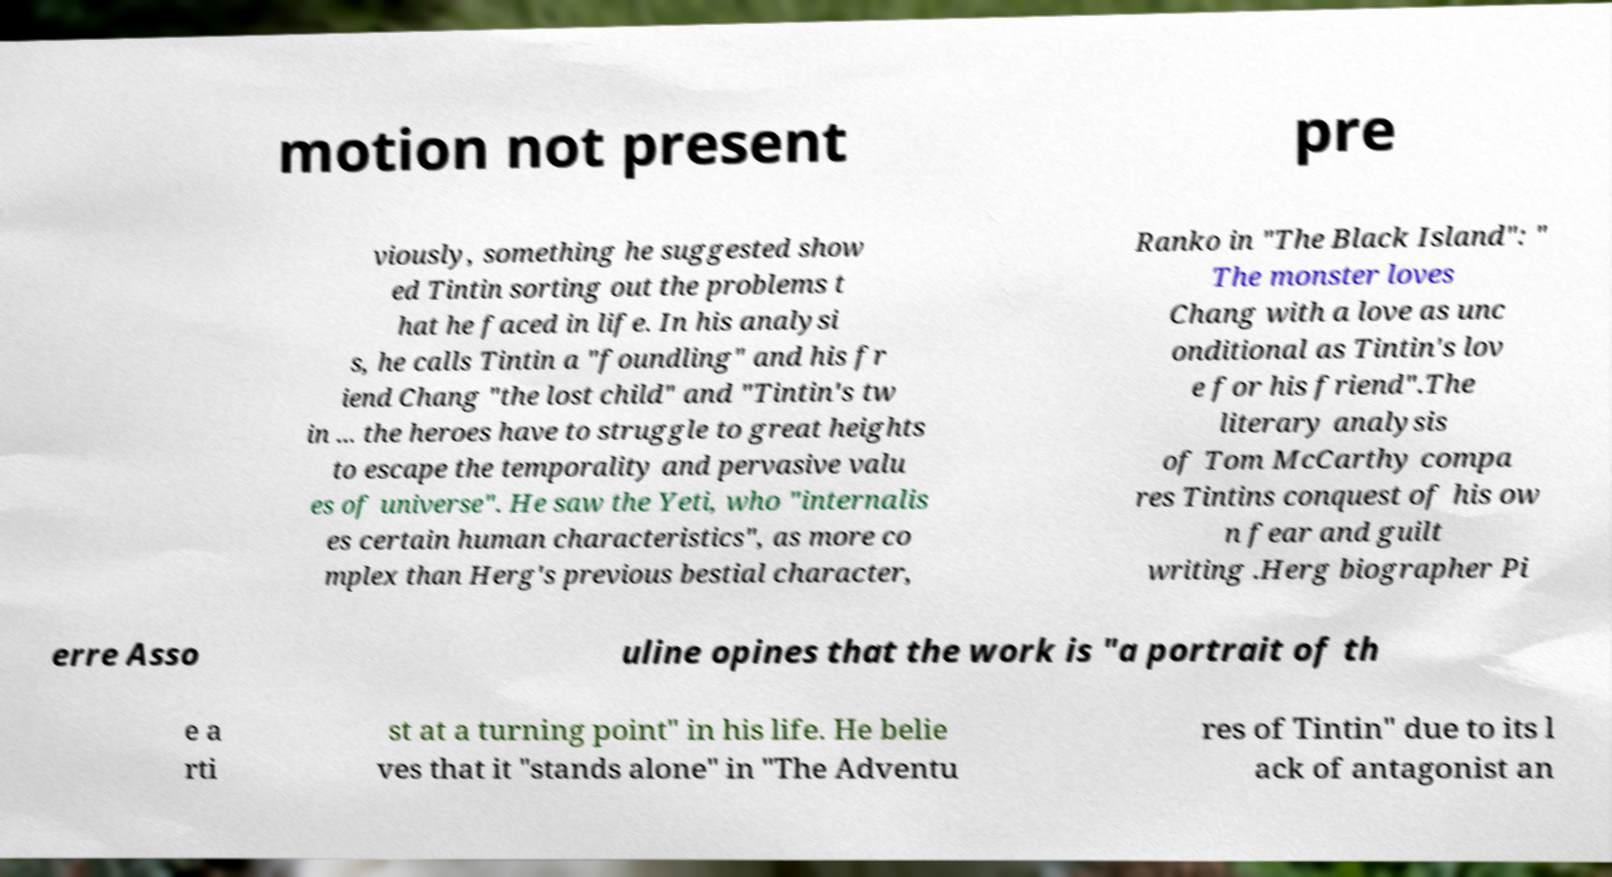Please identify and transcribe the text found in this image. motion not present pre viously, something he suggested show ed Tintin sorting out the problems t hat he faced in life. In his analysi s, he calls Tintin a "foundling" and his fr iend Chang "the lost child" and "Tintin's tw in ... the heroes have to struggle to great heights to escape the temporality and pervasive valu es of universe". He saw the Yeti, who "internalis es certain human characteristics", as more co mplex than Herg's previous bestial character, Ranko in "The Black Island": " The monster loves Chang with a love as unc onditional as Tintin's lov e for his friend".The literary analysis of Tom McCarthy compa res Tintins conquest of his ow n fear and guilt writing .Herg biographer Pi erre Asso uline opines that the work is "a portrait of th e a rti st at a turning point" in his life. He belie ves that it "stands alone" in "The Adventu res of Tintin" due to its l ack of antagonist an 